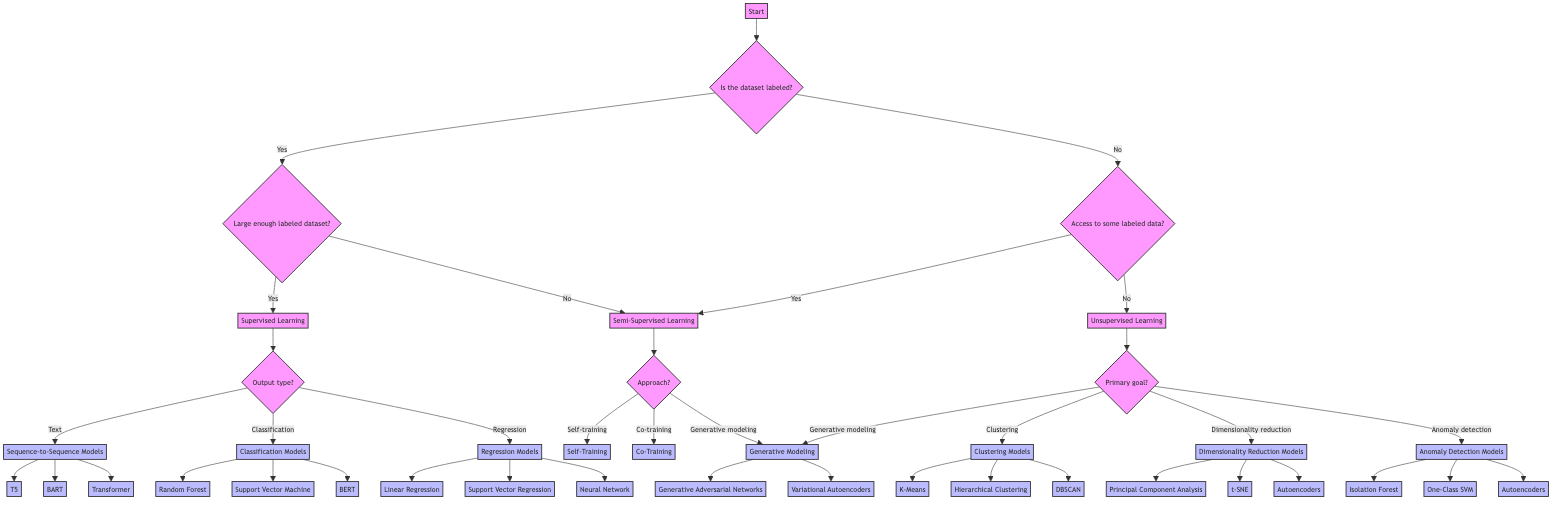What is the first question in the decision tree? The decision tree starts by asking whether the dataset is labeled or unlabeled.
Answer: Is the dataset labeled or unlabeled? What are the three methodologies at the end of the "Supervised Learning" path? Following the "Supervised Learning" node, the diagram branches out to three methodologies based on the type of output required: Sequence-to-Sequence Models, Classification Models, and Regression Models.
Answer: Sequence-to-Sequence Models, Classification Models, Regression Models How many approaches are listed under "Semi-Supervised Learning"? The "Semi-Supervised Learning" node leads to three approaches: Self-Training, Co-Training, and Generative Modeling, making a total of three approaches.
Answer: 3 What is the output type if the dataset is labeled and large enough for training? If the dataset is labeled and large enough for training, the output type will be categorized under Supervised Learning, which further breaks down into specific model types.
Answer: Supervised Learning What are the potential models for "Anomaly Detection"? The "Anomaly Detection Models" under the Unsupervised Learning section lists three potential models: Isolation Forest, One-Class SVM, and Autoencoders.
Answer: Isolation Forest, One-Class SVM, Autoencoders If a model is using "Self-Training", what does it imply? The "Self-Training" approach involves using a small amount of labeled starting data to iteratively label the unlabeled data. This means the model uses its own predictions to improve its labeling of data.
Answer: Use a small amount of labeled starting data to label the unlabeled data iteratively What happens if the dataset is unlabeled and there is no access to some labeled data? If the dataset is unlabeled and there's no access to labeled data, the flow of the diagram leads directly to the Unsupervised Learning category, indicating that methods used will fall into that range.
Answer: Unsupervised Learning Which models fall under "Dimensionality Reduction Models"? The "Dimensionality Reduction Models" node includes models such as Principal Component Analysis, t-SNE, and Autoencoders, indicating effective methods for reducing dimensionality in datasets.
Answer: Principal Component Analysis, t-SNE, Autoencoders 